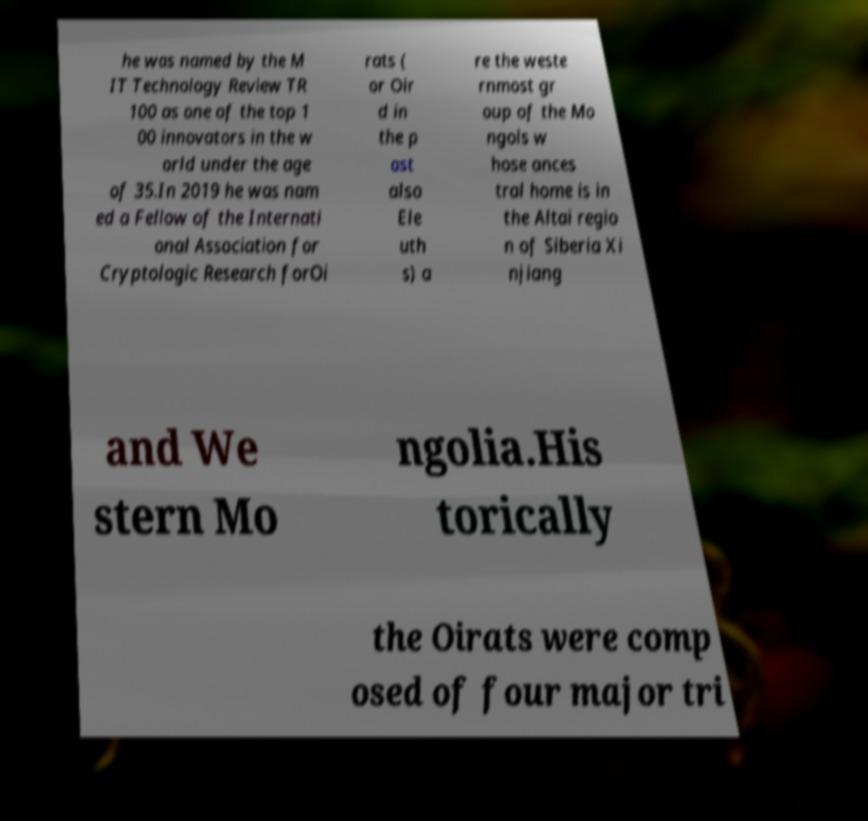Could you assist in decoding the text presented in this image and type it out clearly? he was named by the M IT Technology Review TR 100 as one of the top 1 00 innovators in the w orld under the age of 35.In 2019 he was nam ed a Fellow of the Internati onal Association for Cryptologic Research forOi rats ( or Oir d in the p ast also Ele uth s) a re the weste rnmost gr oup of the Mo ngols w hose ances tral home is in the Altai regio n of Siberia Xi njiang and We stern Mo ngolia.His torically the Oirats were comp osed of four major tri 